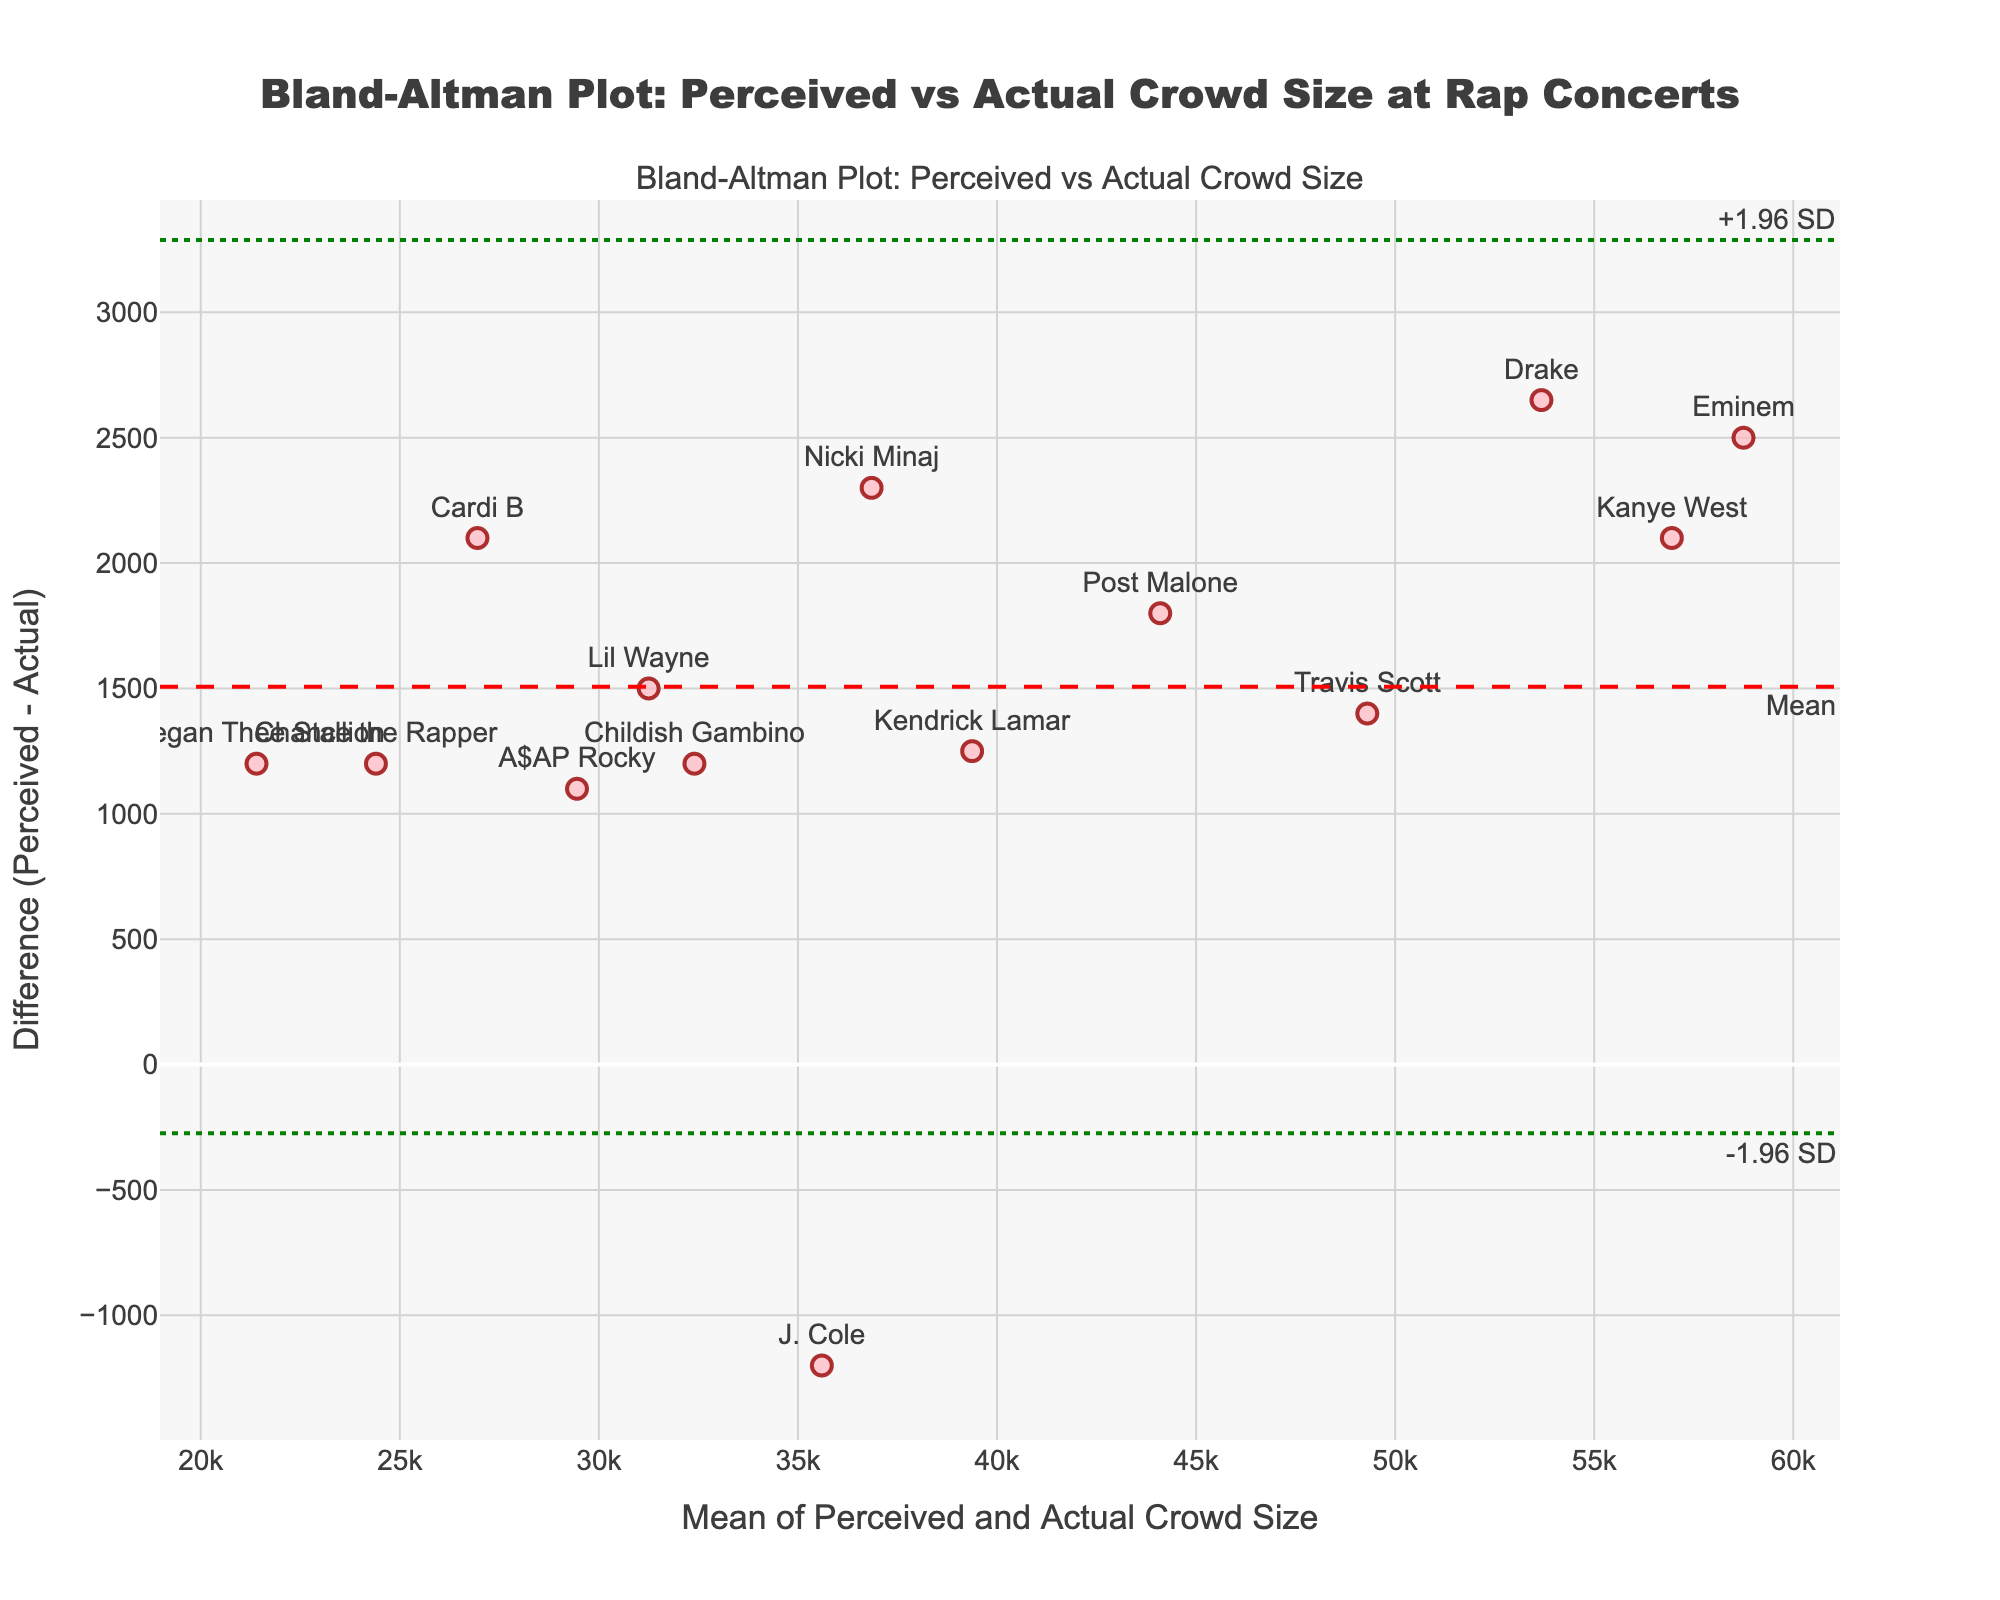What's the title of the plot? The title is displayed at the top of the figure. It reads "Bland-Altman Plot: Perceived vs Actual Crowd Size at Rap Concerts".
Answer: Bland-Altman Plot: Perceived vs Actual Crowd Size at Rap Concerts How many rappers are displayed in the plot? The plot shows a scatter plot where each point represents a rapper. By counting the points, a total of 14 data points (rappers) are represented.
Answer: 14 What's the y-axis label of the plot? The y-axis label is provided along the vertical axis of the plot. It reads "Difference (Perceived - Actual)".
Answer: Difference (Perceived - Actual) What does the mean difference line represent, and what color is it? The mean difference line is marked as a horizontal dashed line and annotated as "Mean". The line is red, indicating the average difference between perceived and actual crowd sizes.
Answer: It represents the average difference and is colored red Which celebrity has the highest perceived crowd size, and what's the mean of their perceived and actual attendance? By locating the points on the plot, Eminem has the highest perceived crowd size at 60,000. The actual attendance is 57,500, so the mean is (60,000 + 57,500) / 2 = 58,750.
Answer: Eminem, 58,750 What is the point with the smallest difference between perceived and actual crowd sizes? By visually inspecting the shortest vertical distance from the zero line on the y-axis, the smallest difference appears near the point for J. Cole. The difference is around -1,200.
Answer: J. Cole Which rapper's perceived attendance was overestimated by the largest amount? By finding the point with the maximum positive difference on the y-axis, Drake's point stands out. His perceived crowd size is overestimated by about 2,650.
Answer: Drake Who has the closest met agreement lines (+1.96 SD, -1.96 SD) and how is their difference from the mean line? Points closest to the limit lines are those at the extreme ends of the y-axis. Drake and Cardi B have points closest to these agreement lines, corresponding to variations farthest from the mean difference.
Answer: Drake, Cardi B 